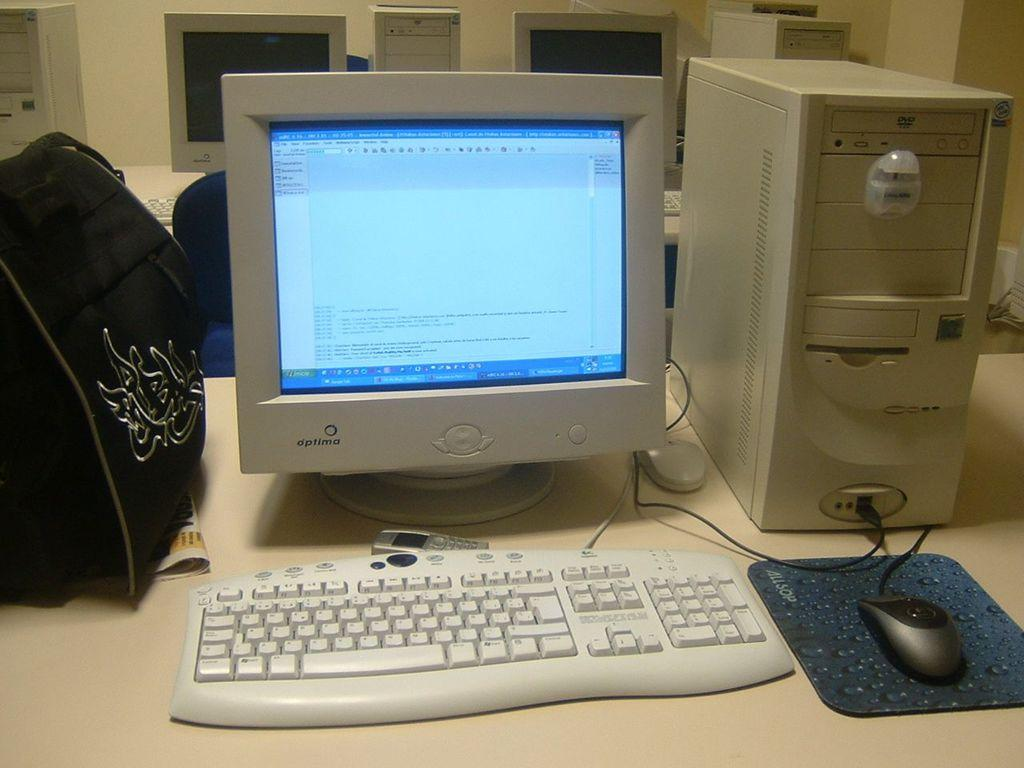<image>
Provide a brief description of the given image. A desktop computer running a word processing program. 